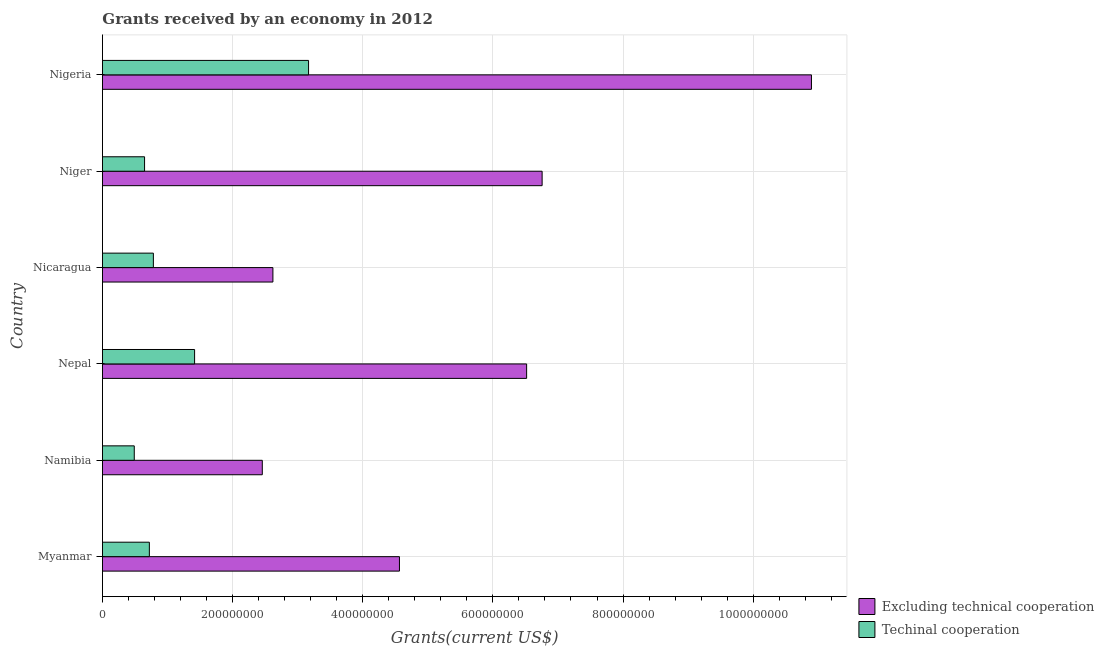How many different coloured bars are there?
Offer a terse response. 2. Are the number of bars per tick equal to the number of legend labels?
Your response must be concise. Yes. Are the number of bars on each tick of the Y-axis equal?
Your answer should be very brief. Yes. How many bars are there on the 4th tick from the bottom?
Your response must be concise. 2. What is the label of the 2nd group of bars from the top?
Give a very brief answer. Niger. In how many cases, is the number of bars for a given country not equal to the number of legend labels?
Make the answer very short. 0. What is the amount of grants received(including technical cooperation) in Myanmar?
Provide a succinct answer. 7.21e+07. Across all countries, what is the maximum amount of grants received(excluding technical cooperation)?
Ensure brevity in your answer.  1.09e+09. Across all countries, what is the minimum amount of grants received(including technical cooperation)?
Keep it short and to the point. 4.89e+07. In which country was the amount of grants received(excluding technical cooperation) maximum?
Keep it short and to the point. Nigeria. In which country was the amount of grants received(excluding technical cooperation) minimum?
Provide a short and direct response. Namibia. What is the total amount of grants received(excluding technical cooperation) in the graph?
Keep it short and to the point. 3.38e+09. What is the difference between the amount of grants received(excluding technical cooperation) in Niger and that in Nigeria?
Your response must be concise. -4.14e+08. What is the difference between the amount of grants received(including technical cooperation) in Namibia and the amount of grants received(excluding technical cooperation) in Myanmar?
Your answer should be compact. -4.08e+08. What is the average amount of grants received(excluding technical cooperation) per country?
Your answer should be very brief. 5.64e+08. What is the difference between the amount of grants received(including technical cooperation) and amount of grants received(excluding technical cooperation) in Niger?
Give a very brief answer. -6.11e+08. In how many countries, is the amount of grants received(including technical cooperation) greater than 840000000 US$?
Provide a succinct answer. 0. What is the ratio of the amount of grants received(excluding technical cooperation) in Namibia to that in Nepal?
Your answer should be very brief. 0.38. Is the amount of grants received(excluding technical cooperation) in Nicaragua less than that in Nigeria?
Your answer should be very brief. Yes. What is the difference between the highest and the second highest amount of grants received(including technical cooperation)?
Provide a short and direct response. 1.75e+08. What is the difference between the highest and the lowest amount of grants received(including technical cooperation)?
Keep it short and to the point. 2.68e+08. In how many countries, is the amount of grants received(including technical cooperation) greater than the average amount of grants received(including technical cooperation) taken over all countries?
Provide a short and direct response. 2. Is the sum of the amount of grants received(including technical cooperation) in Niger and Nigeria greater than the maximum amount of grants received(excluding technical cooperation) across all countries?
Your response must be concise. No. What does the 1st bar from the top in Myanmar represents?
Give a very brief answer. Techinal cooperation. What does the 2nd bar from the bottom in Namibia represents?
Offer a very short reply. Techinal cooperation. How many bars are there?
Your response must be concise. 12. Does the graph contain grids?
Offer a terse response. Yes. How many legend labels are there?
Offer a terse response. 2. What is the title of the graph?
Your answer should be very brief. Grants received by an economy in 2012. What is the label or title of the X-axis?
Offer a very short reply. Grants(current US$). What is the Grants(current US$) of Excluding technical cooperation in Myanmar?
Make the answer very short. 4.56e+08. What is the Grants(current US$) of Techinal cooperation in Myanmar?
Provide a succinct answer. 7.21e+07. What is the Grants(current US$) of Excluding technical cooperation in Namibia?
Offer a very short reply. 2.46e+08. What is the Grants(current US$) of Techinal cooperation in Namibia?
Your response must be concise. 4.89e+07. What is the Grants(current US$) in Excluding technical cooperation in Nepal?
Provide a succinct answer. 6.52e+08. What is the Grants(current US$) in Techinal cooperation in Nepal?
Keep it short and to the point. 1.42e+08. What is the Grants(current US$) in Excluding technical cooperation in Nicaragua?
Offer a terse response. 2.62e+08. What is the Grants(current US$) of Techinal cooperation in Nicaragua?
Make the answer very short. 7.82e+07. What is the Grants(current US$) in Excluding technical cooperation in Niger?
Provide a short and direct response. 6.76e+08. What is the Grants(current US$) of Techinal cooperation in Niger?
Provide a succinct answer. 6.47e+07. What is the Grants(current US$) of Excluding technical cooperation in Nigeria?
Give a very brief answer. 1.09e+09. What is the Grants(current US$) of Techinal cooperation in Nigeria?
Keep it short and to the point. 3.17e+08. Across all countries, what is the maximum Grants(current US$) in Excluding technical cooperation?
Your answer should be compact. 1.09e+09. Across all countries, what is the maximum Grants(current US$) in Techinal cooperation?
Your response must be concise. 3.17e+08. Across all countries, what is the minimum Grants(current US$) of Excluding technical cooperation?
Your answer should be very brief. 2.46e+08. Across all countries, what is the minimum Grants(current US$) in Techinal cooperation?
Provide a short and direct response. 4.89e+07. What is the total Grants(current US$) in Excluding technical cooperation in the graph?
Provide a short and direct response. 3.38e+09. What is the total Grants(current US$) of Techinal cooperation in the graph?
Your answer should be very brief. 7.22e+08. What is the difference between the Grants(current US$) in Excluding technical cooperation in Myanmar and that in Namibia?
Your answer should be compact. 2.11e+08. What is the difference between the Grants(current US$) in Techinal cooperation in Myanmar and that in Namibia?
Your answer should be compact. 2.32e+07. What is the difference between the Grants(current US$) of Excluding technical cooperation in Myanmar and that in Nepal?
Make the answer very short. -1.95e+08. What is the difference between the Grants(current US$) in Techinal cooperation in Myanmar and that in Nepal?
Your answer should be very brief. -6.95e+07. What is the difference between the Grants(current US$) of Excluding technical cooperation in Myanmar and that in Nicaragua?
Give a very brief answer. 1.94e+08. What is the difference between the Grants(current US$) of Techinal cooperation in Myanmar and that in Nicaragua?
Offer a very short reply. -6.17e+06. What is the difference between the Grants(current US$) of Excluding technical cooperation in Myanmar and that in Niger?
Keep it short and to the point. -2.19e+08. What is the difference between the Grants(current US$) in Techinal cooperation in Myanmar and that in Niger?
Keep it short and to the point. 7.36e+06. What is the difference between the Grants(current US$) in Excluding technical cooperation in Myanmar and that in Nigeria?
Your response must be concise. -6.33e+08. What is the difference between the Grants(current US$) of Techinal cooperation in Myanmar and that in Nigeria?
Provide a succinct answer. -2.45e+08. What is the difference between the Grants(current US$) in Excluding technical cooperation in Namibia and that in Nepal?
Your answer should be compact. -4.06e+08. What is the difference between the Grants(current US$) in Techinal cooperation in Namibia and that in Nepal?
Provide a succinct answer. -9.27e+07. What is the difference between the Grants(current US$) in Excluding technical cooperation in Namibia and that in Nicaragua?
Your answer should be compact. -1.63e+07. What is the difference between the Grants(current US$) in Techinal cooperation in Namibia and that in Nicaragua?
Offer a terse response. -2.94e+07. What is the difference between the Grants(current US$) of Excluding technical cooperation in Namibia and that in Niger?
Your answer should be compact. -4.30e+08. What is the difference between the Grants(current US$) of Techinal cooperation in Namibia and that in Niger?
Offer a terse response. -1.58e+07. What is the difference between the Grants(current US$) of Excluding technical cooperation in Namibia and that in Nigeria?
Make the answer very short. -8.44e+08. What is the difference between the Grants(current US$) of Techinal cooperation in Namibia and that in Nigeria?
Provide a succinct answer. -2.68e+08. What is the difference between the Grants(current US$) in Excluding technical cooperation in Nepal and that in Nicaragua?
Your response must be concise. 3.90e+08. What is the difference between the Grants(current US$) in Techinal cooperation in Nepal and that in Nicaragua?
Keep it short and to the point. 6.34e+07. What is the difference between the Grants(current US$) of Excluding technical cooperation in Nepal and that in Niger?
Your answer should be compact. -2.38e+07. What is the difference between the Grants(current US$) of Techinal cooperation in Nepal and that in Niger?
Make the answer very short. 7.69e+07. What is the difference between the Grants(current US$) in Excluding technical cooperation in Nepal and that in Nigeria?
Give a very brief answer. -4.38e+08. What is the difference between the Grants(current US$) in Techinal cooperation in Nepal and that in Nigeria?
Provide a succinct answer. -1.75e+08. What is the difference between the Grants(current US$) in Excluding technical cooperation in Nicaragua and that in Niger?
Make the answer very short. -4.14e+08. What is the difference between the Grants(current US$) in Techinal cooperation in Nicaragua and that in Niger?
Give a very brief answer. 1.35e+07. What is the difference between the Grants(current US$) of Excluding technical cooperation in Nicaragua and that in Nigeria?
Your answer should be very brief. -8.28e+08. What is the difference between the Grants(current US$) in Techinal cooperation in Nicaragua and that in Nigeria?
Keep it short and to the point. -2.38e+08. What is the difference between the Grants(current US$) of Excluding technical cooperation in Niger and that in Nigeria?
Your response must be concise. -4.14e+08. What is the difference between the Grants(current US$) in Techinal cooperation in Niger and that in Nigeria?
Your answer should be very brief. -2.52e+08. What is the difference between the Grants(current US$) of Excluding technical cooperation in Myanmar and the Grants(current US$) of Techinal cooperation in Namibia?
Offer a terse response. 4.08e+08. What is the difference between the Grants(current US$) of Excluding technical cooperation in Myanmar and the Grants(current US$) of Techinal cooperation in Nepal?
Provide a succinct answer. 3.15e+08. What is the difference between the Grants(current US$) of Excluding technical cooperation in Myanmar and the Grants(current US$) of Techinal cooperation in Nicaragua?
Offer a terse response. 3.78e+08. What is the difference between the Grants(current US$) in Excluding technical cooperation in Myanmar and the Grants(current US$) in Techinal cooperation in Niger?
Your answer should be compact. 3.92e+08. What is the difference between the Grants(current US$) of Excluding technical cooperation in Myanmar and the Grants(current US$) of Techinal cooperation in Nigeria?
Your answer should be compact. 1.40e+08. What is the difference between the Grants(current US$) in Excluding technical cooperation in Namibia and the Grants(current US$) in Techinal cooperation in Nepal?
Give a very brief answer. 1.04e+08. What is the difference between the Grants(current US$) in Excluding technical cooperation in Namibia and the Grants(current US$) in Techinal cooperation in Nicaragua?
Ensure brevity in your answer.  1.67e+08. What is the difference between the Grants(current US$) in Excluding technical cooperation in Namibia and the Grants(current US$) in Techinal cooperation in Niger?
Your answer should be very brief. 1.81e+08. What is the difference between the Grants(current US$) in Excluding technical cooperation in Namibia and the Grants(current US$) in Techinal cooperation in Nigeria?
Ensure brevity in your answer.  -7.11e+07. What is the difference between the Grants(current US$) in Excluding technical cooperation in Nepal and the Grants(current US$) in Techinal cooperation in Nicaragua?
Give a very brief answer. 5.74e+08. What is the difference between the Grants(current US$) of Excluding technical cooperation in Nepal and the Grants(current US$) of Techinal cooperation in Niger?
Ensure brevity in your answer.  5.87e+08. What is the difference between the Grants(current US$) of Excluding technical cooperation in Nepal and the Grants(current US$) of Techinal cooperation in Nigeria?
Provide a succinct answer. 3.35e+08. What is the difference between the Grants(current US$) of Excluding technical cooperation in Nicaragua and the Grants(current US$) of Techinal cooperation in Niger?
Ensure brevity in your answer.  1.97e+08. What is the difference between the Grants(current US$) in Excluding technical cooperation in Nicaragua and the Grants(current US$) in Techinal cooperation in Nigeria?
Your answer should be compact. -5.48e+07. What is the difference between the Grants(current US$) of Excluding technical cooperation in Niger and the Grants(current US$) of Techinal cooperation in Nigeria?
Provide a succinct answer. 3.59e+08. What is the average Grants(current US$) of Excluding technical cooperation per country?
Provide a short and direct response. 5.64e+08. What is the average Grants(current US$) in Techinal cooperation per country?
Keep it short and to the point. 1.20e+08. What is the difference between the Grants(current US$) in Excluding technical cooperation and Grants(current US$) in Techinal cooperation in Myanmar?
Ensure brevity in your answer.  3.84e+08. What is the difference between the Grants(current US$) in Excluding technical cooperation and Grants(current US$) in Techinal cooperation in Namibia?
Offer a terse response. 1.97e+08. What is the difference between the Grants(current US$) of Excluding technical cooperation and Grants(current US$) of Techinal cooperation in Nepal?
Provide a succinct answer. 5.10e+08. What is the difference between the Grants(current US$) of Excluding technical cooperation and Grants(current US$) of Techinal cooperation in Nicaragua?
Offer a terse response. 1.84e+08. What is the difference between the Grants(current US$) in Excluding technical cooperation and Grants(current US$) in Techinal cooperation in Niger?
Keep it short and to the point. 6.11e+08. What is the difference between the Grants(current US$) of Excluding technical cooperation and Grants(current US$) of Techinal cooperation in Nigeria?
Make the answer very short. 7.73e+08. What is the ratio of the Grants(current US$) of Excluding technical cooperation in Myanmar to that in Namibia?
Offer a very short reply. 1.86. What is the ratio of the Grants(current US$) in Techinal cooperation in Myanmar to that in Namibia?
Make the answer very short. 1.47. What is the ratio of the Grants(current US$) in Excluding technical cooperation in Myanmar to that in Nepal?
Your answer should be compact. 0.7. What is the ratio of the Grants(current US$) of Techinal cooperation in Myanmar to that in Nepal?
Ensure brevity in your answer.  0.51. What is the ratio of the Grants(current US$) in Excluding technical cooperation in Myanmar to that in Nicaragua?
Provide a short and direct response. 1.74. What is the ratio of the Grants(current US$) of Techinal cooperation in Myanmar to that in Nicaragua?
Make the answer very short. 0.92. What is the ratio of the Grants(current US$) of Excluding technical cooperation in Myanmar to that in Niger?
Keep it short and to the point. 0.68. What is the ratio of the Grants(current US$) in Techinal cooperation in Myanmar to that in Niger?
Provide a short and direct response. 1.11. What is the ratio of the Grants(current US$) of Excluding technical cooperation in Myanmar to that in Nigeria?
Keep it short and to the point. 0.42. What is the ratio of the Grants(current US$) of Techinal cooperation in Myanmar to that in Nigeria?
Give a very brief answer. 0.23. What is the ratio of the Grants(current US$) in Excluding technical cooperation in Namibia to that in Nepal?
Make the answer very short. 0.38. What is the ratio of the Grants(current US$) in Techinal cooperation in Namibia to that in Nepal?
Offer a very short reply. 0.35. What is the ratio of the Grants(current US$) in Excluding technical cooperation in Namibia to that in Nicaragua?
Make the answer very short. 0.94. What is the ratio of the Grants(current US$) of Techinal cooperation in Namibia to that in Nicaragua?
Give a very brief answer. 0.62. What is the ratio of the Grants(current US$) of Excluding technical cooperation in Namibia to that in Niger?
Keep it short and to the point. 0.36. What is the ratio of the Grants(current US$) in Techinal cooperation in Namibia to that in Niger?
Your answer should be very brief. 0.76. What is the ratio of the Grants(current US$) of Excluding technical cooperation in Namibia to that in Nigeria?
Keep it short and to the point. 0.23. What is the ratio of the Grants(current US$) in Techinal cooperation in Namibia to that in Nigeria?
Keep it short and to the point. 0.15. What is the ratio of the Grants(current US$) in Excluding technical cooperation in Nepal to that in Nicaragua?
Make the answer very short. 2.49. What is the ratio of the Grants(current US$) in Techinal cooperation in Nepal to that in Nicaragua?
Keep it short and to the point. 1.81. What is the ratio of the Grants(current US$) in Excluding technical cooperation in Nepal to that in Niger?
Provide a succinct answer. 0.96. What is the ratio of the Grants(current US$) in Techinal cooperation in Nepal to that in Niger?
Your answer should be compact. 2.19. What is the ratio of the Grants(current US$) in Excluding technical cooperation in Nepal to that in Nigeria?
Your answer should be compact. 0.6. What is the ratio of the Grants(current US$) of Techinal cooperation in Nepal to that in Nigeria?
Provide a succinct answer. 0.45. What is the ratio of the Grants(current US$) of Excluding technical cooperation in Nicaragua to that in Niger?
Provide a succinct answer. 0.39. What is the ratio of the Grants(current US$) in Techinal cooperation in Nicaragua to that in Niger?
Ensure brevity in your answer.  1.21. What is the ratio of the Grants(current US$) of Excluding technical cooperation in Nicaragua to that in Nigeria?
Your response must be concise. 0.24. What is the ratio of the Grants(current US$) of Techinal cooperation in Nicaragua to that in Nigeria?
Offer a terse response. 0.25. What is the ratio of the Grants(current US$) of Excluding technical cooperation in Niger to that in Nigeria?
Make the answer very short. 0.62. What is the ratio of the Grants(current US$) in Techinal cooperation in Niger to that in Nigeria?
Offer a terse response. 0.2. What is the difference between the highest and the second highest Grants(current US$) in Excluding technical cooperation?
Give a very brief answer. 4.14e+08. What is the difference between the highest and the second highest Grants(current US$) of Techinal cooperation?
Give a very brief answer. 1.75e+08. What is the difference between the highest and the lowest Grants(current US$) of Excluding technical cooperation?
Give a very brief answer. 8.44e+08. What is the difference between the highest and the lowest Grants(current US$) of Techinal cooperation?
Make the answer very short. 2.68e+08. 